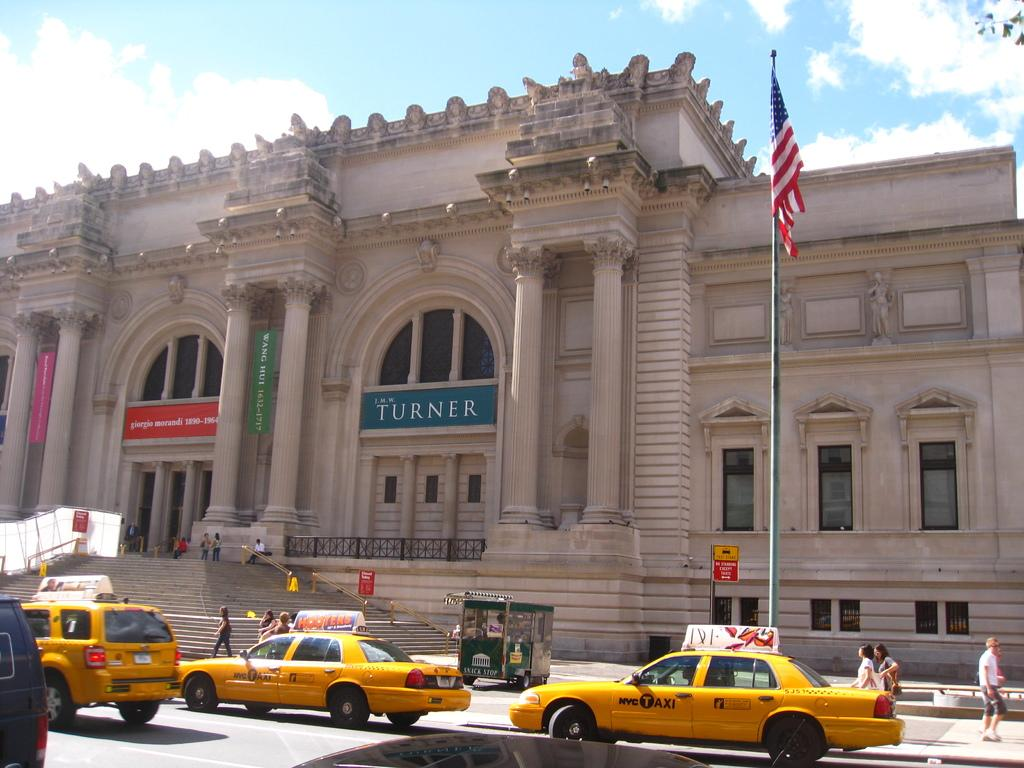<image>
Summarize the visual content of the image. three yellow taxi cabs are driving in front of a building that has the banner called turner. 